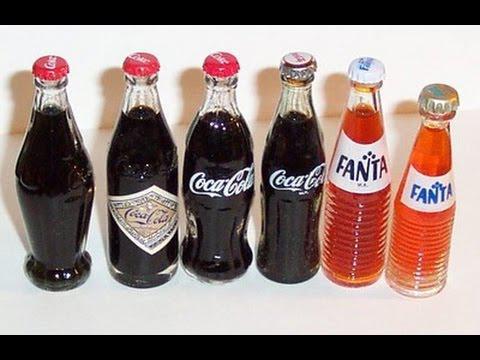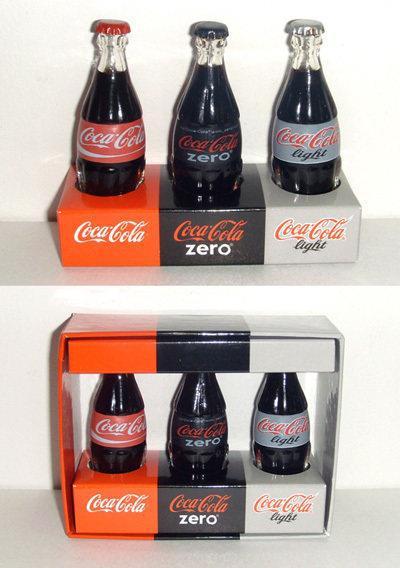The first image is the image on the left, the second image is the image on the right. Examine the images to the left and right. Is the description "There are fewer than twelve bottles in total." accurate? Answer yes or no. No. The first image is the image on the left, the second image is the image on the right. Considering the images on both sides, is "The left and right image contains the same number of  bottles." valid? Answer yes or no. Yes. 